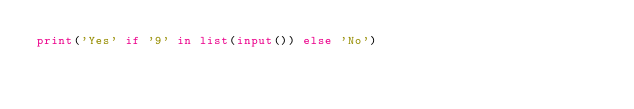Convert code to text. <code><loc_0><loc_0><loc_500><loc_500><_Python_>print('Yes' if '9' in list(input()) else 'No')</code> 